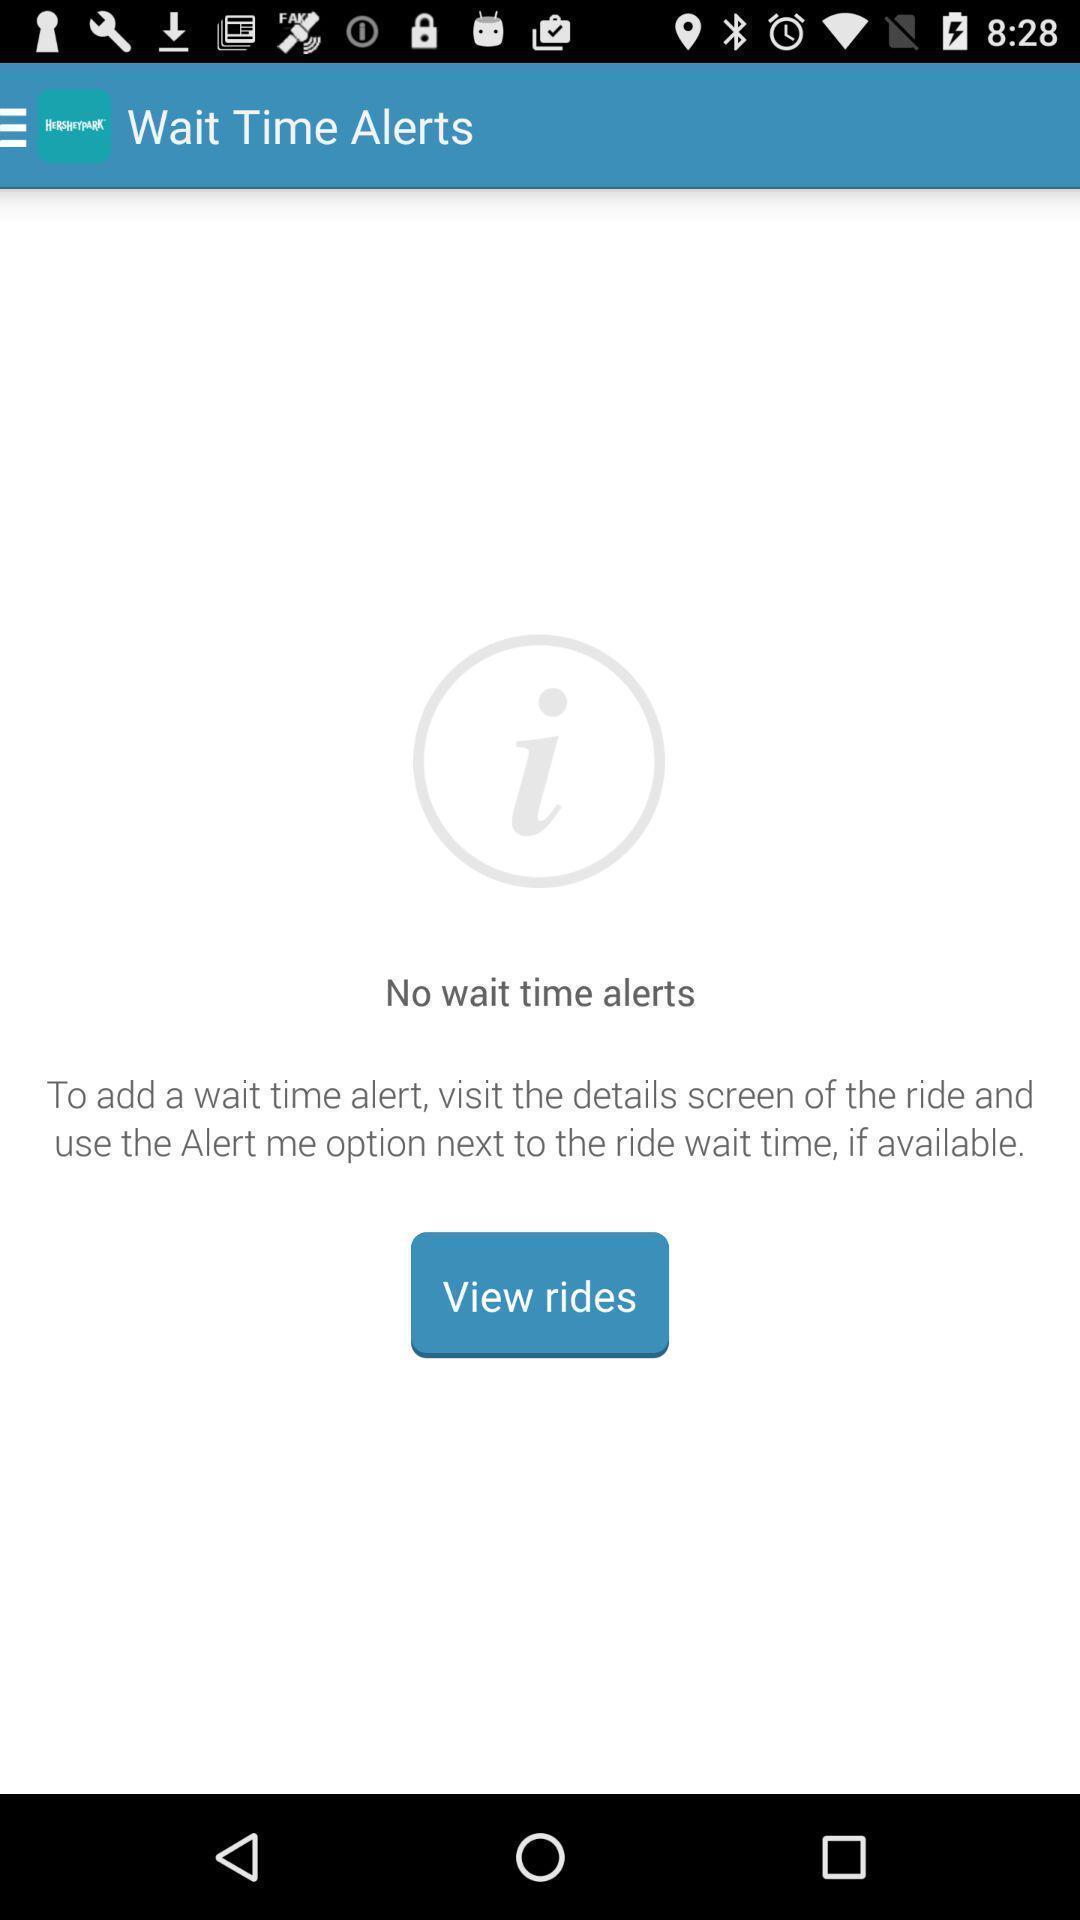What details can you identify in this image? Screen displaying remainder messages information. 